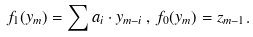Convert formula to latex. <formula><loc_0><loc_0><loc_500><loc_500>f _ { 1 } ( y _ { m } ) = \sum a _ { i } \cdot y _ { m - i } \, , \, f _ { 0 } ( y _ { m } ) = z _ { m - 1 } .</formula> 